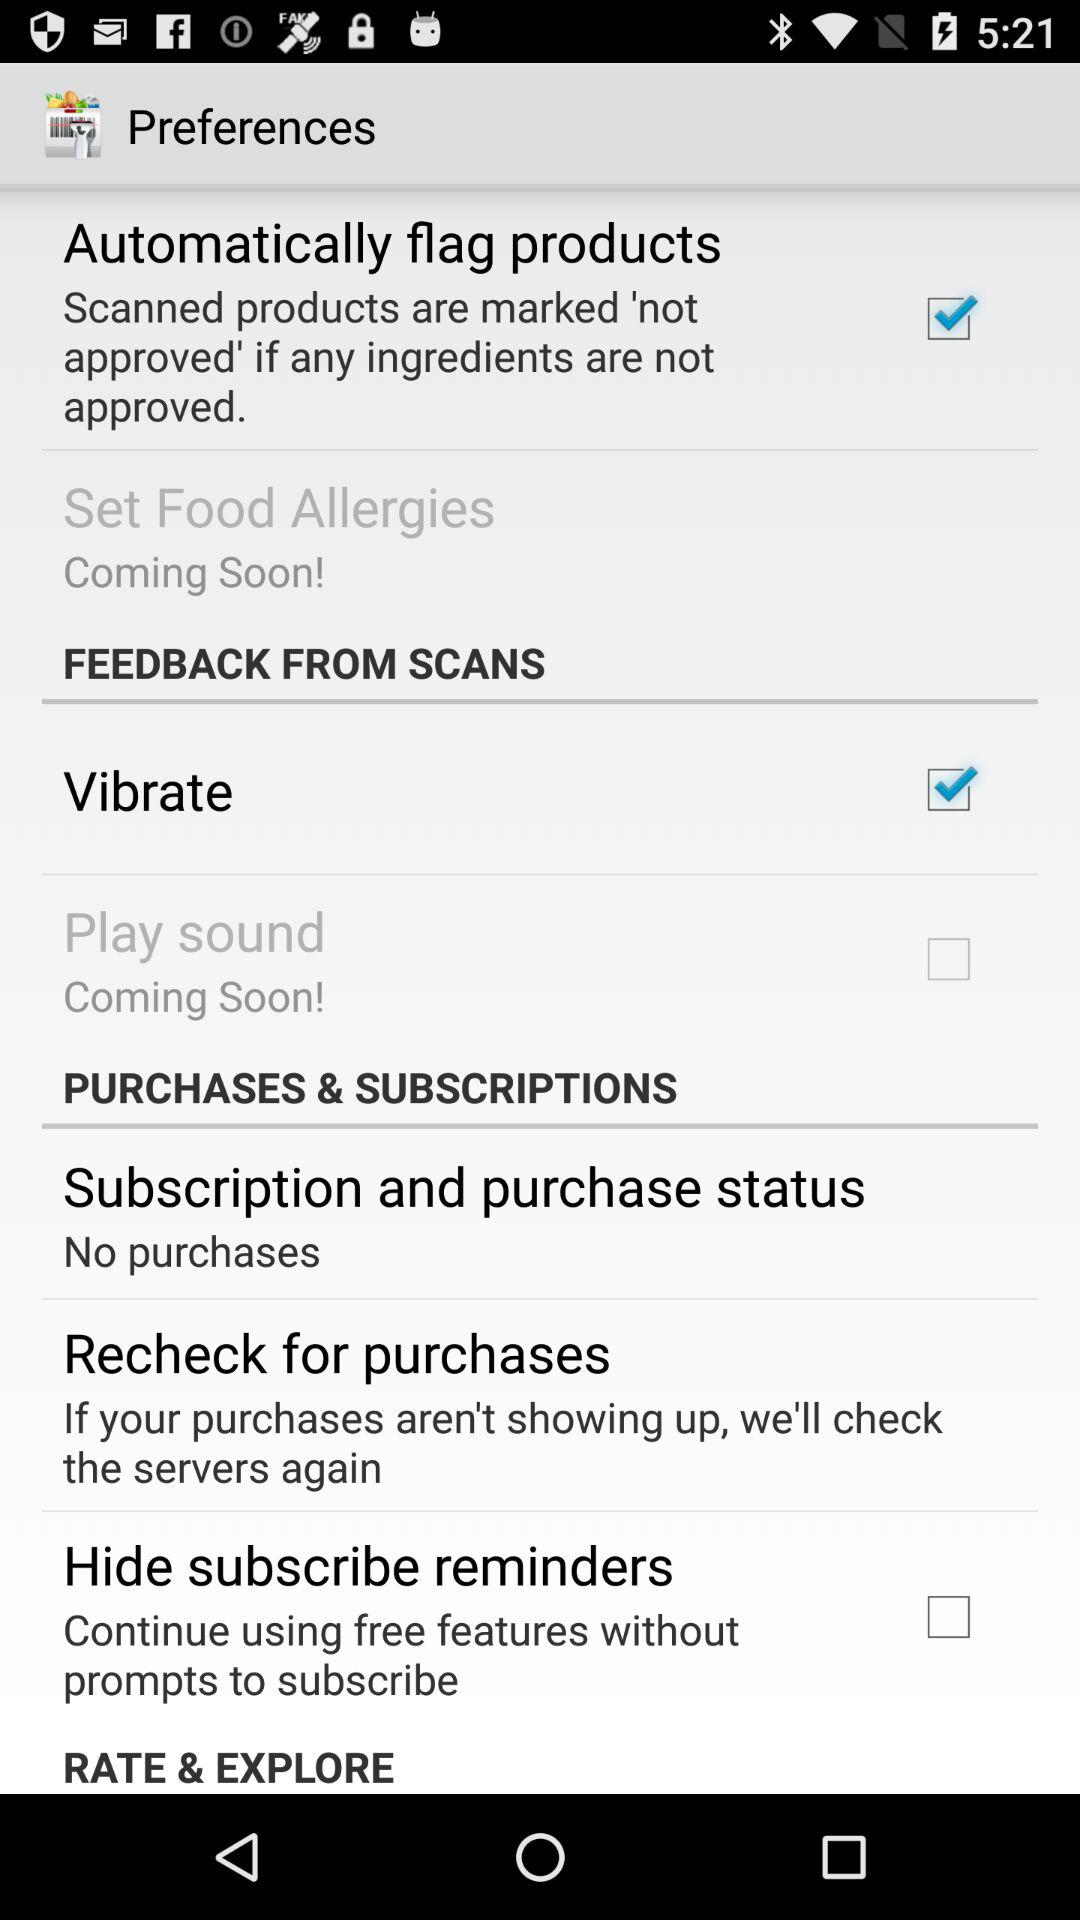What is the status of "Vibrate"? The status of "Vibrate" is "on". 